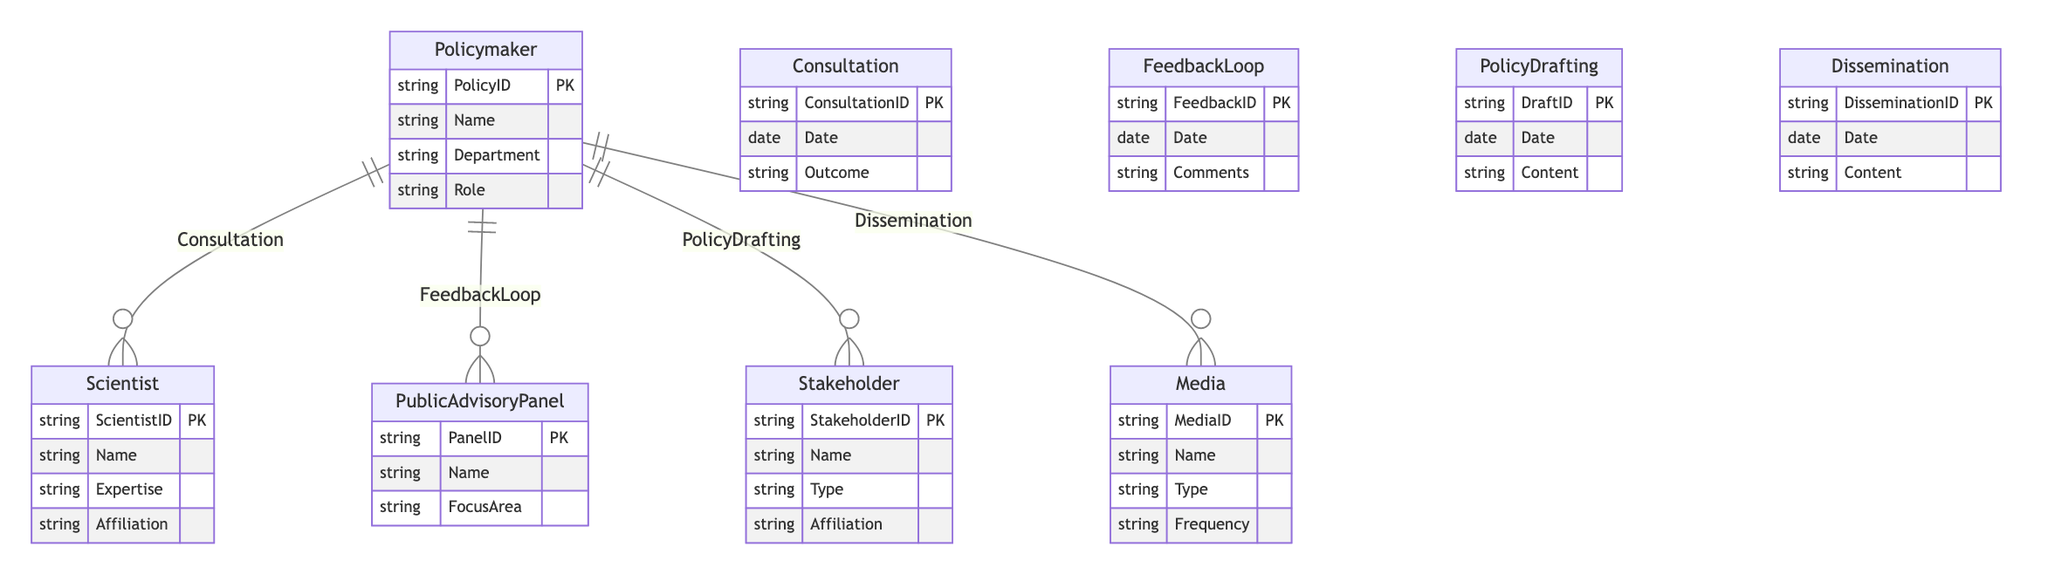What entities are depicted in the diagram? The diagram includes the following entities: Policymaker, Scientist, Public Advisory Panel, Stakeholder, and Media. Each of these represents a distinct role within the context of public and stakeholder engagement in scientific policy-making.
Answer: Policymaker, Scientist, Public Advisory Panel, Stakeholder, Media How many relationships are shown in the diagram? The diagram displays four relationships: Consultation, Feedback Loop, Policy Drafting, and Dissemination. Each relationship connects Policymakers with other entities reflecting various engagement activities.
Answer: Four What is the relationship between Policymaker and Scientist called? The relationship between Policymaker and Scientist is termed "Consultation," indicating a process where the Policymaker seeks advice or information from Scientists for policy development.
Answer: Consultation What are the attributes of the Media entity? The attributes of the Media entity are MediaID, Name, Type, and Frequency. These attributes inform about the identification, characteristics, and usage frequency of the media involved in policy dissemination.
Answer: MediaID, Name, Type, Frequency What is the purpose of the Feedback Loop relationship? The Feedback Loop relationship aims to facilitate communication between Policymakers and Public Advisory Panels, enabling Policymakers to receive comments and insights that can inform their policy decisions.
Answer: Facilitate communication and receive comments Which entity is involved in the Policy Drafting process along with the Policymaker? The Stakeholder entity is involved in the Policy Drafting process along with the Policymaker, indicating that stakeholders contribute to the creation and refinement of policy documents.
Answer: Stakeholder Explain the significance of the Dissemination relationship. The Dissemination relationship is significant because it illustrates how Policymakers share relevant information and policy outcomes with the Media, which plays a crucial role in informing the public and stakeholders about policy developments. This relationship is essential for transparency and engagement.
Answer: Share information and policy outcomes with the Media What is the outcome attribute associated with the Consultation relationship? The outcome attribute associated with the Consultation relationship refers to the results or conclusions derived from the consultation process between Policymakers and Scientists, providing insights on the effectiveness of the interaction.
Answer: Outcome How does the Feedback Loop enhance the policymaking process? The Feedback Loop enhances the policymaking process by incorporating diverse perspectives and insights from Public Advisory Panels, ensuring that policies are more inclusive, better-informed, and responsive to community needs. This iterative process can significantly improve the quality of policies.
Answer: Incorporate diverse perspectives and insights What type of information is contained in the Policy Drafting relationship? The Policy Drafting relationship contains information such as the DraftID, Date, and Content, detailing the specifics of the drafting process, including when the draft occurred and the subject matter of the content being drafted.
Answer: DraftID, Date, Content 